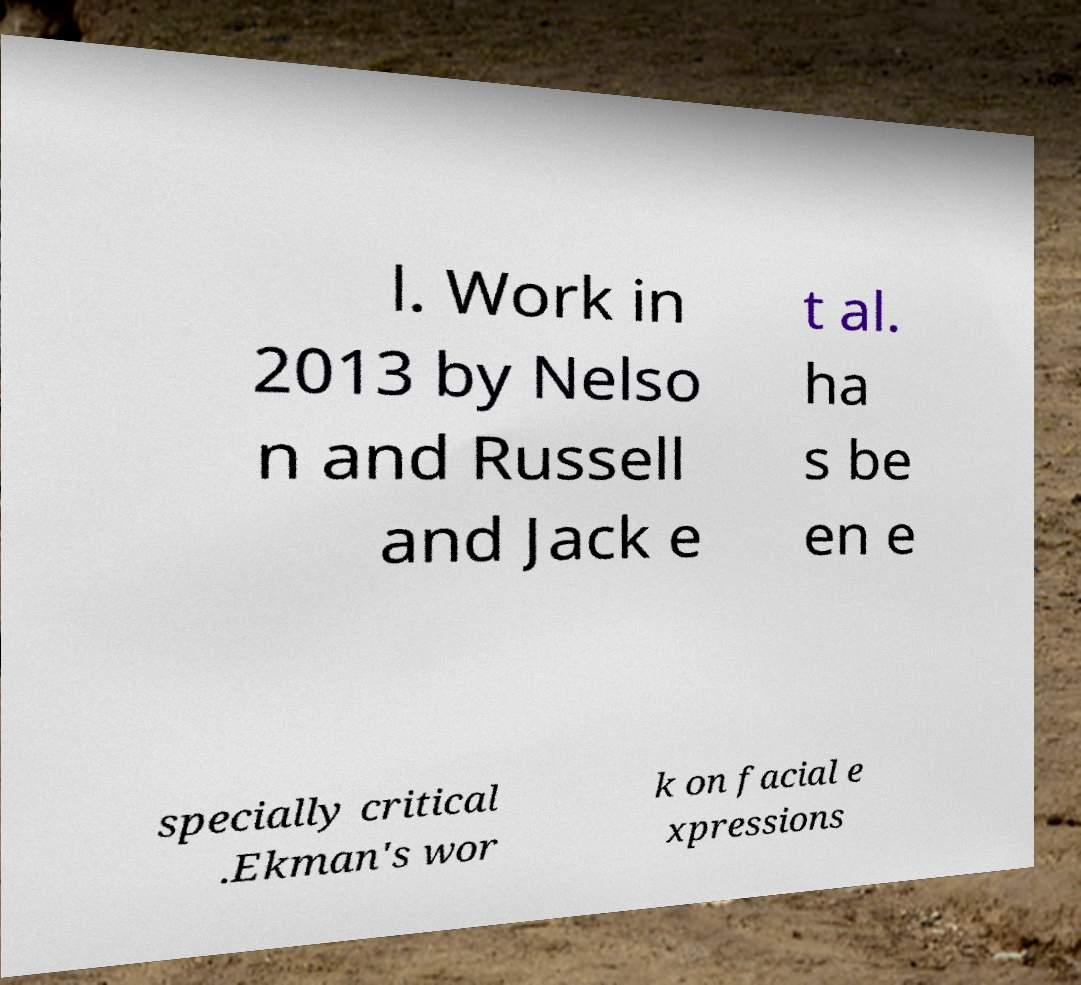Can you accurately transcribe the text from the provided image for me? l. Work in 2013 by Nelso n and Russell and Jack e t al. ha s be en e specially critical .Ekman's wor k on facial e xpressions 